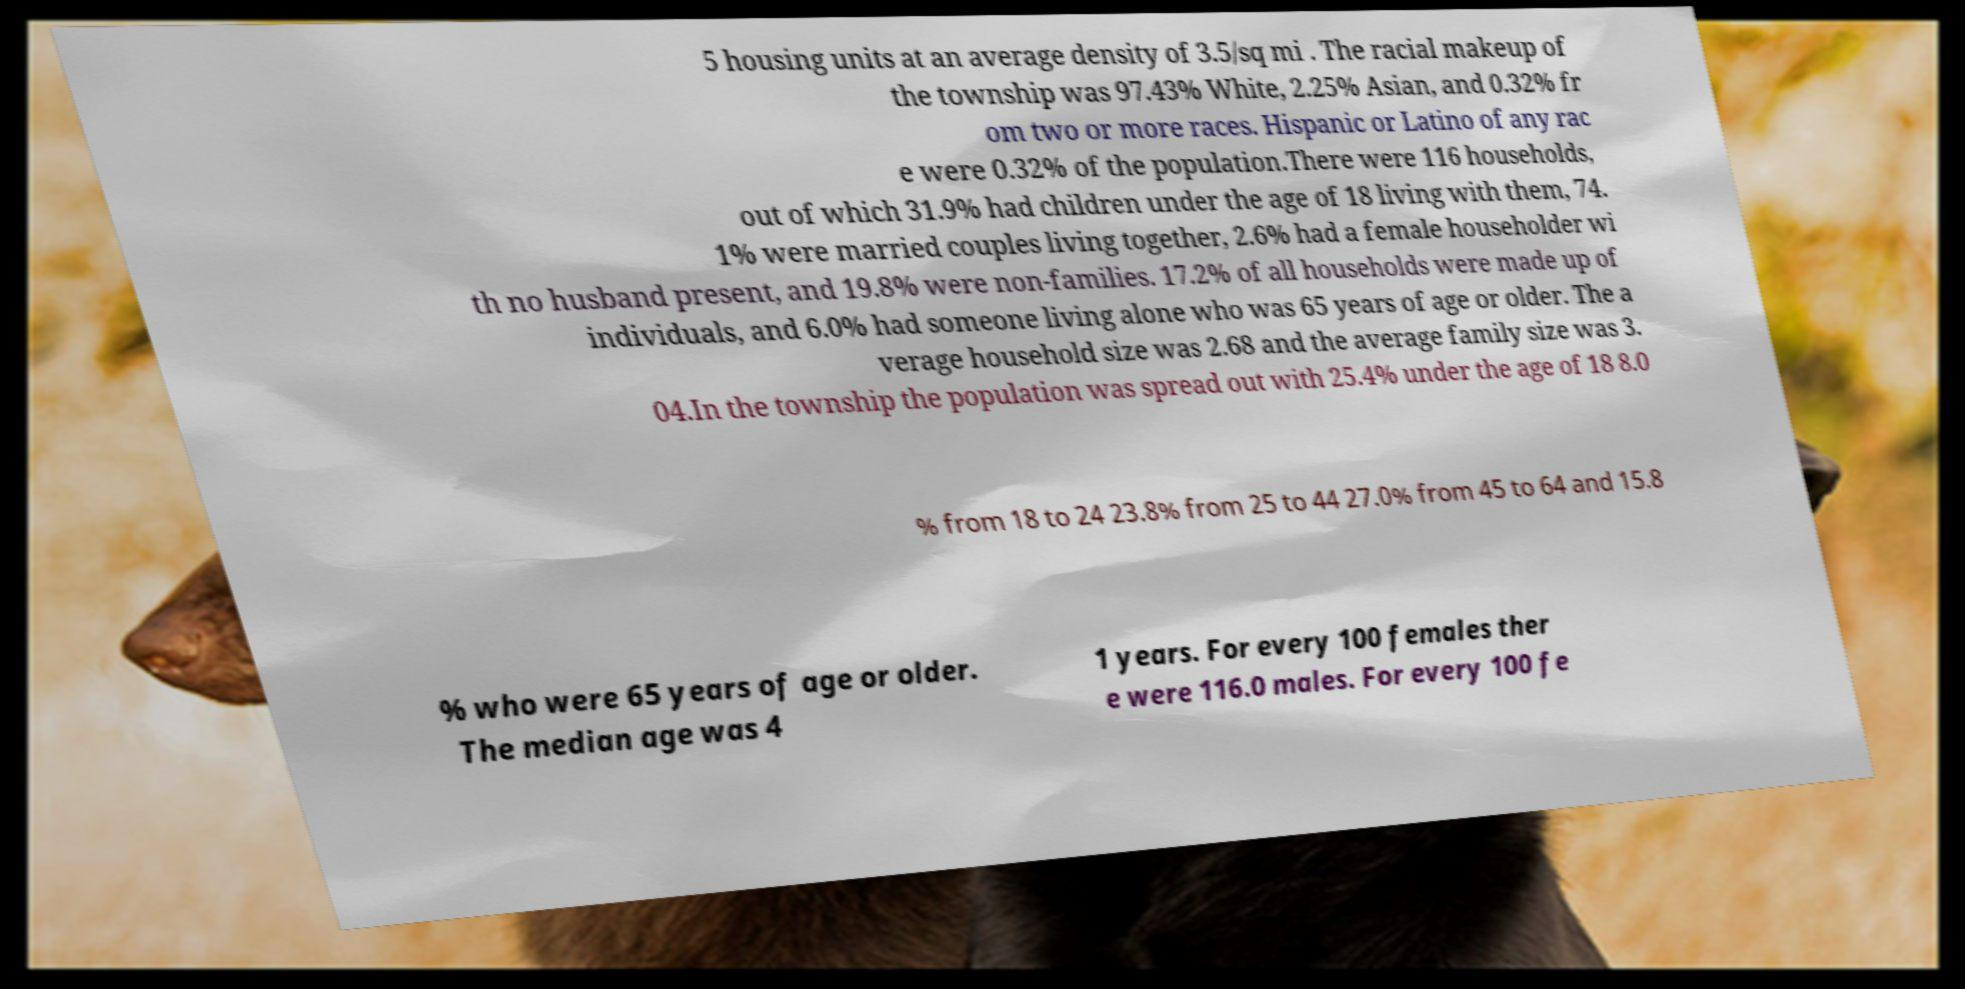I need the written content from this picture converted into text. Can you do that? 5 housing units at an average density of 3.5/sq mi . The racial makeup of the township was 97.43% White, 2.25% Asian, and 0.32% fr om two or more races. Hispanic or Latino of any rac e were 0.32% of the population.There were 116 households, out of which 31.9% had children under the age of 18 living with them, 74. 1% were married couples living together, 2.6% had a female householder wi th no husband present, and 19.8% were non-families. 17.2% of all households were made up of individuals, and 6.0% had someone living alone who was 65 years of age or older. The a verage household size was 2.68 and the average family size was 3. 04.In the township the population was spread out with 25.4% under the age of 18 8.0 % from 18 to 24 23.8% from 25 to 44 27.0% from 45 to 64 and 15.8 % who were 65 years of age or older. The median age was 4 1 years. For every 100 females ther e were 116.0 males. For every 100 fe 